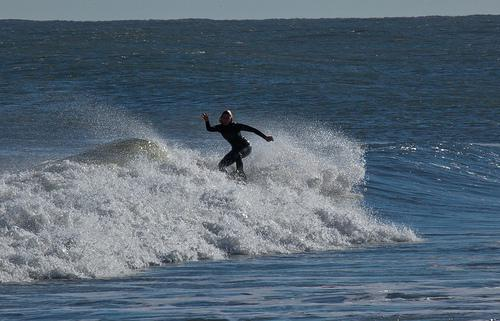Question: where is the person at the moment?
Choices:
A. On the beach.
B. In the lake.
C. On the boat.
D. On a wave.
Answer with the letter. Answer: D Question: what is this person wearing?
Choices:
A. Wet suit.
B. Bikini.
C. Towel.
D. Nothing.
Answer with the letter. Answer: A Question: who is pictured?
Choices:
A. A swimmer.
B. A surfer.
C. A diver.
D. A runner.
Answer with the letter. Answer: B 